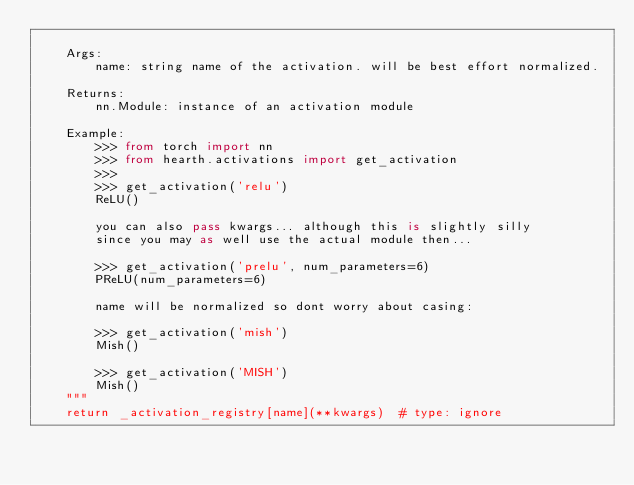<code> <loc_0><loc_0><loc_500><loc_500><_Python_>
    Args:
        name: string name of the activation. will be best effort normalized.

    Returns:
        nn.Module: instance of an activation module

    Example:
        >>> from torch import nn
        >>> from hearth.activations import get_activation
        >>>
        >>> get_activation('relu')
        ReLU()

        you can also pass kwargs... although this is slightly silly
        since you may as well use the actual module then...

        >>> get_activation('prelu', num_parameters=6)
        PReLU(num_parameters=6)

        name will be normalized so dont worry about casing:

        >>> get_activation('mish')
        Mish()

        >>> get_activation('MISH')
        Mish()
    """
    return _activation_registry[name](**kwargs)  # type: ignore
</code> 